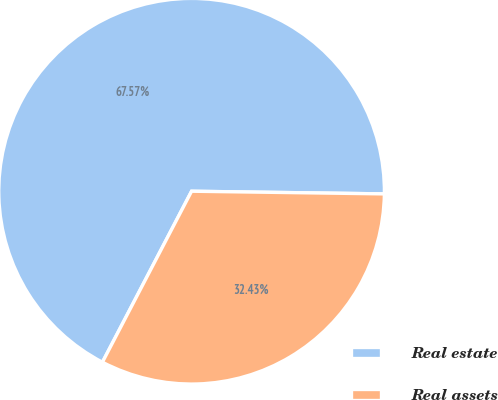Convert chart to OTSL. <chart><loc_0><loc_0><loc_500><loc_500><pie_chart><fcel>Real estate<fcel>Real assets<nl><fcel>67.57%<fcel>32.43%<nl></chart> 